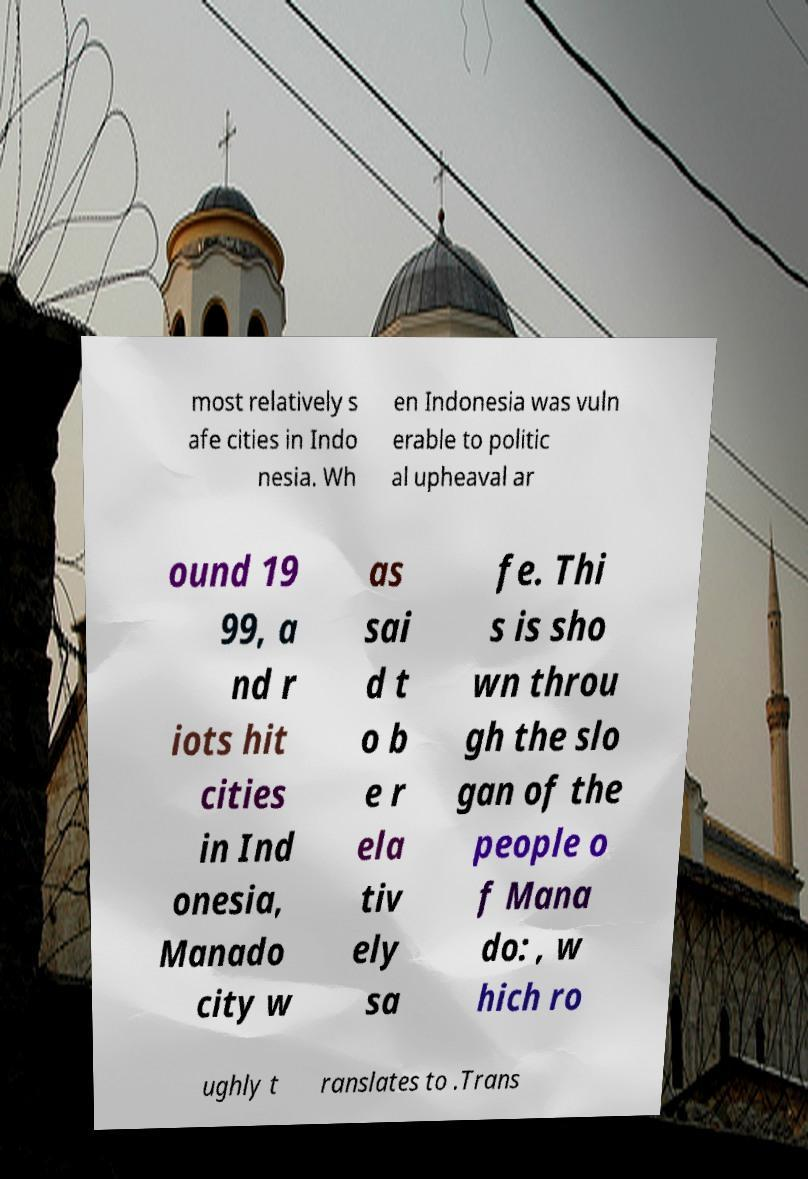Could you extract and type out the text from this image? most relatively s afe cities in Indo nesia. Wh en Indonesia was vuln erable to politic al upheaval ar ound 19 99, a nd r iots hit cities in Ind onesia, Manado city w as sai d t o b e r ela tiv ely sa fe. Thi s is sho wn throu gh the slo gan of the people o f Mana do: , w hich ro ughly t ranslates to .Trans 